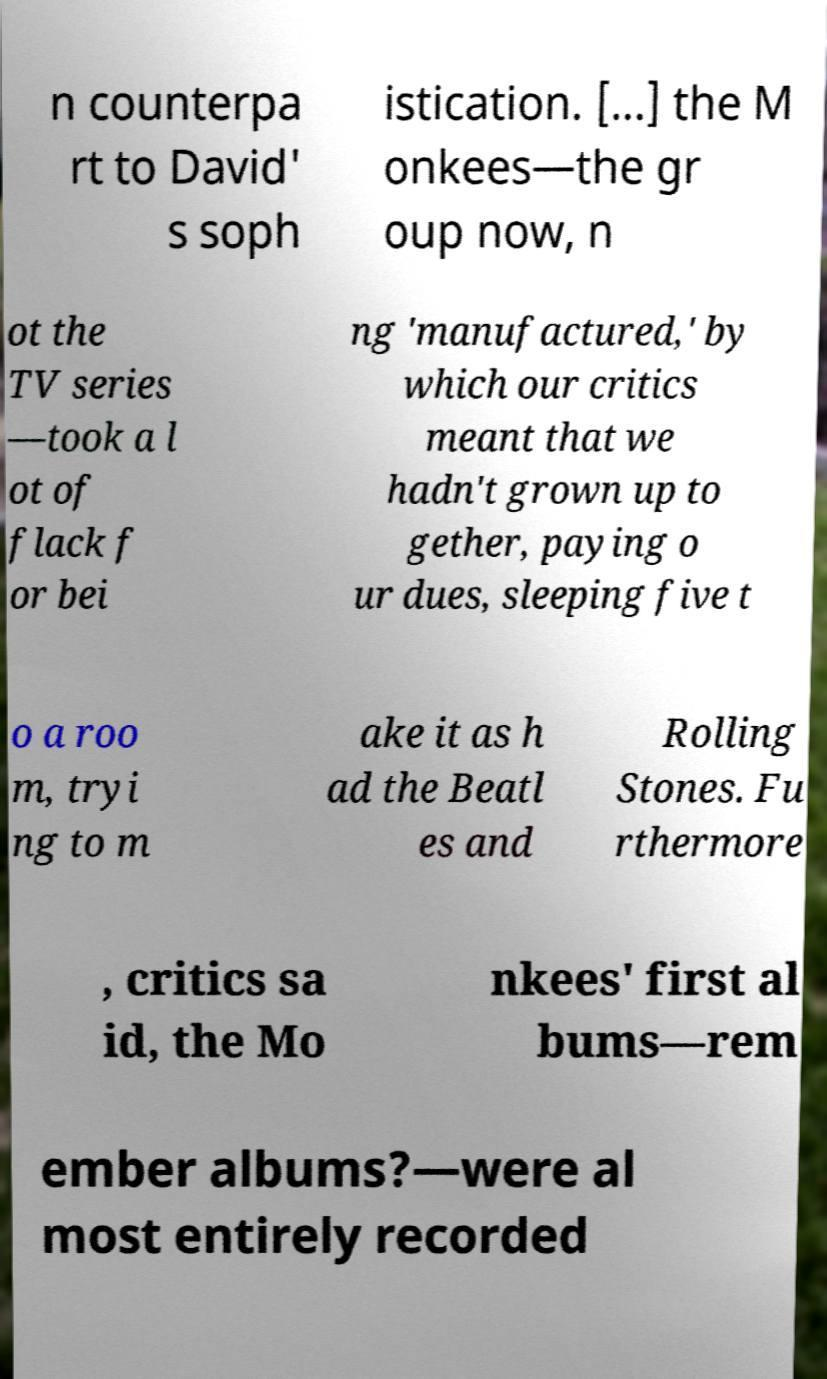Please read and relay the text visible in this image. What does it say? n counterpa rt to David' s soph istication. [...] the M onkees—the gr oup now, n ot the TV series —took a l ot of flack f or bei ng 'manufactured,' by which our critics meant that we hadn't grown up to gether, paying o ur dues, sleeping five t o a roo m, tryi ng to m ake it as h ad the Beatl es and Rolling Stones. Fu rthermore , critics sa id, the Mo nkees' first al bums—rem ember albums?—were al most entirely recorded 